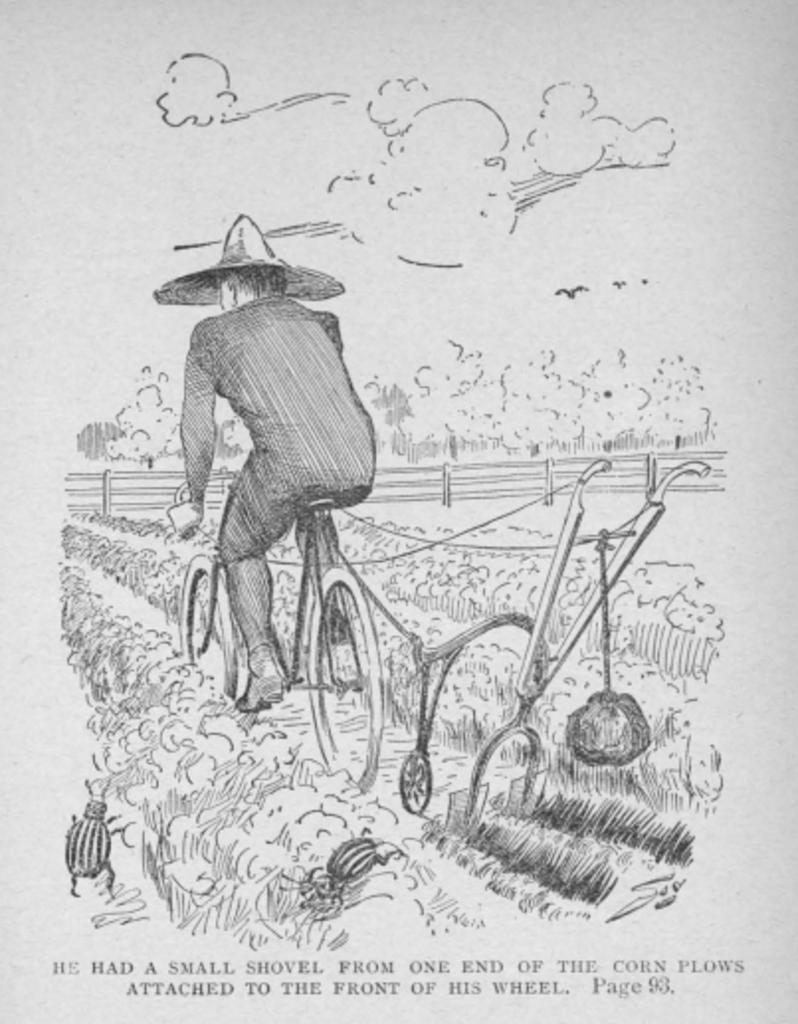What is depicted in the foreground of the image? There is a sketch of a person riding a cycle in the foreground. What is the person riding the cycle on? The person is riding the cycle on a path. What can be seen on either side of the path? There are plants and trees on either side of the path. What type of barrier is present on either side of the path? There is a railing on either side of the path. What is visible in the background of the image? The sky is visible in the image, and clouds are present in the sky. Can you tell me how many giraffes are standing next to the person riding the cycle in the image? There are no giraffes present in the image; it features a sketch of a person riding a cycle on a path with plants, trees, and railings. What type of pickle is being used as a decoration on the person's cycle in the image? There is no pickle present in the image, and the person's cycle is not being used as a decoration. 